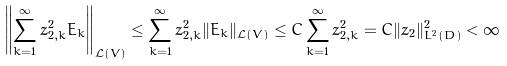<formula> <loc_0><loc_0><loc_500><loc_500>\left \| \sum _ { k = 1 } ^ { \infty } z _ { 2 , k } ^ { 2 } E _ { k } \right \| _ { \mathcal { L } ( V ) } \leq \sum _ { k = 1 } ^ { \infty } z _ { 2 , k } ^ { 2 } \| E _ { k } \| _ { \mathcal { L } ( V ) } \leq C \sum _ { k = 1 } ^ { \infty } z _ { 2 , k } ^ { 2 } = C \| z _ { 2 } \| _ { L ^ { 2 } ( D ) } ^ { 2 } < \infty</formula> 